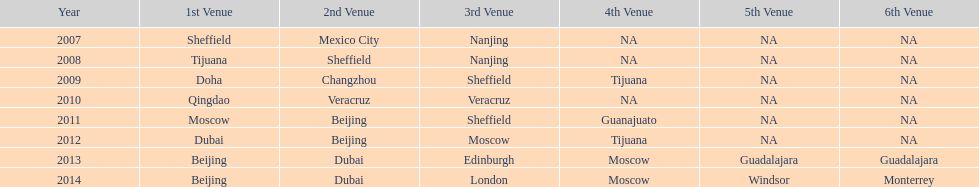Which is the only year that mexico is on a venue 2007. 